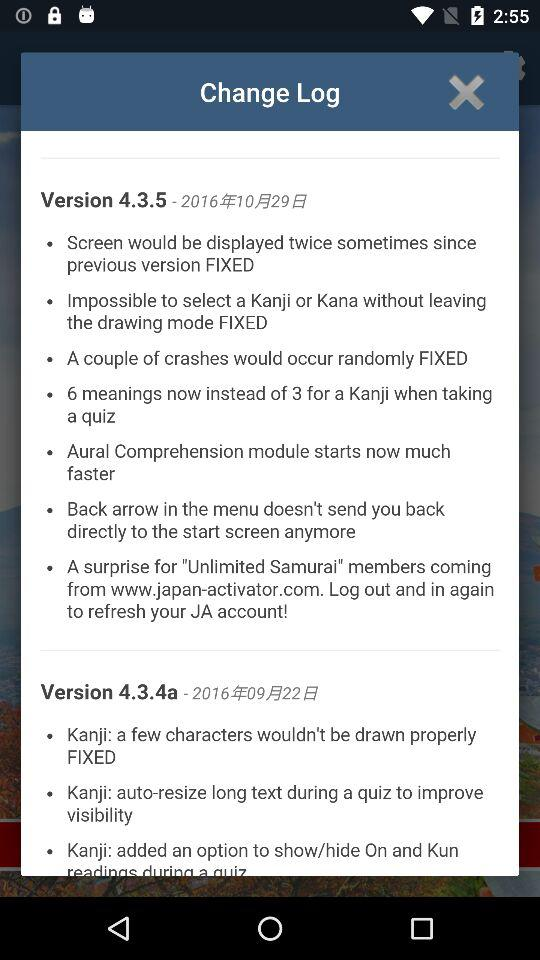What issues are fixed in version 4.3.5? The fixed issues are "Screen would be displayed twice sometimes since previous version FIXED", "Screen would be displayed twice sometimes since previous version FIXED", "A couple of crashes would occur randomly FIXED", "6 meanings now instead of 3 for a kanji when taking a quiz", "Aural Comprehension module starts now much faster", "Back arrow in the menu doesn't send you back directly to the start screen anymore", and "A surprise for "Unlimited Samurai" members coming from www.japan-activator.com. Log out and in again to refresh your JA account!". 